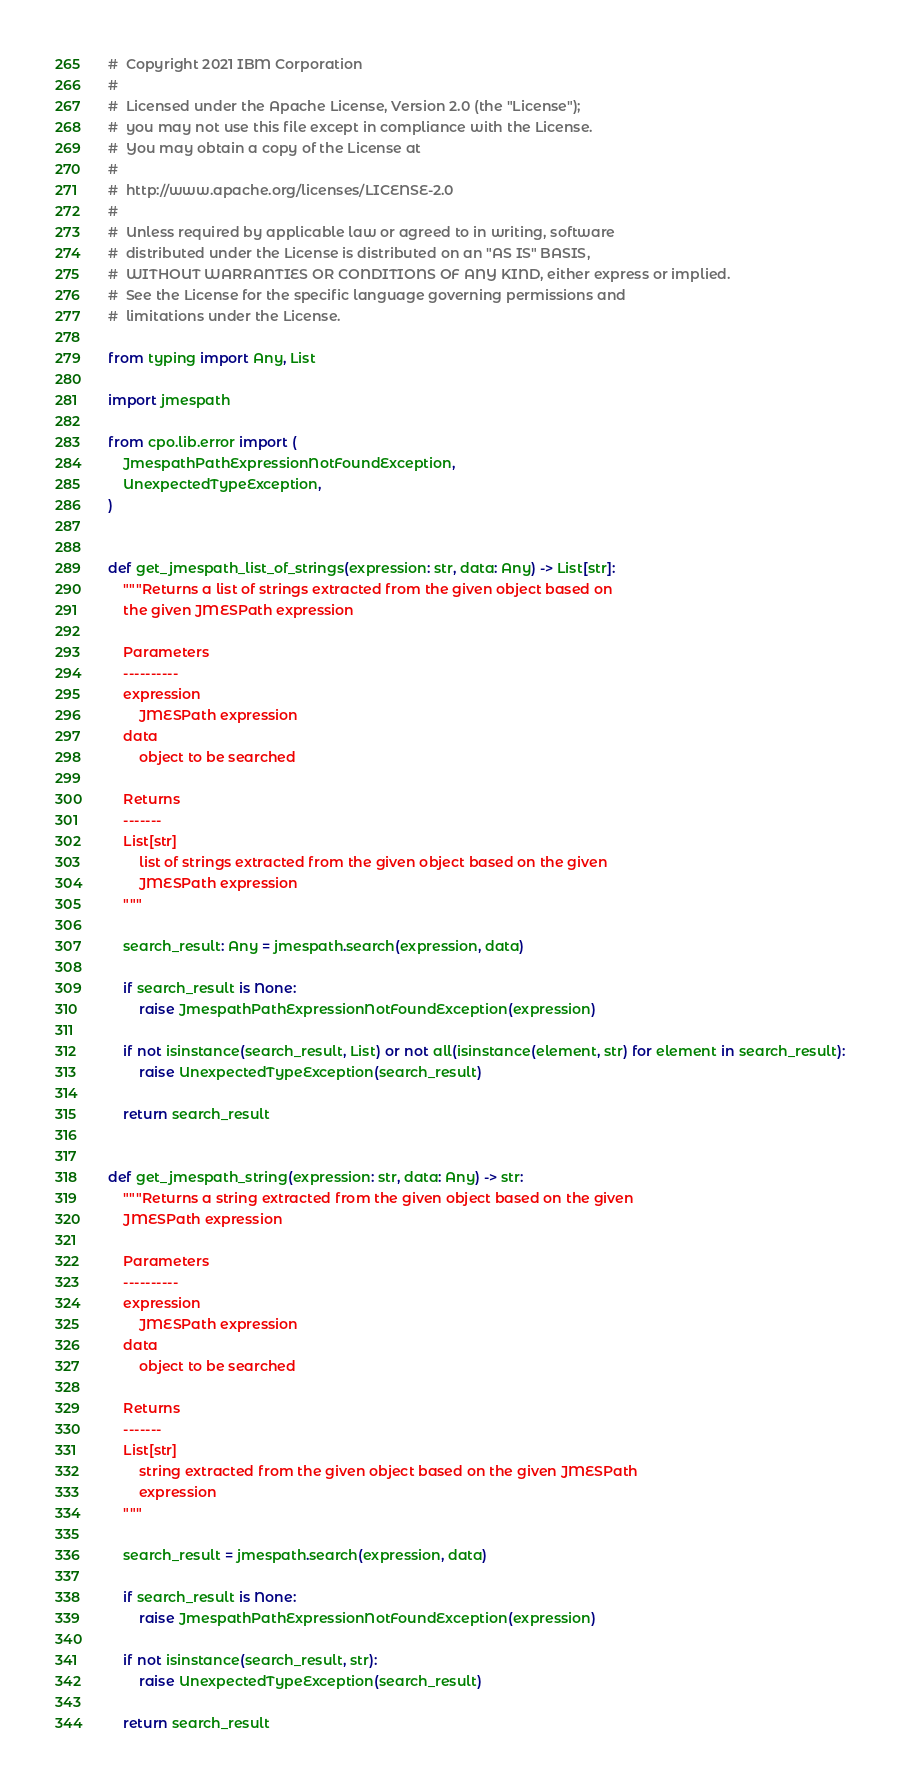<code> <loc_0><loc_0><loc_500><loc_500><_Python_>#  Copyright 2021 IBM Corporation
#
#  Licensed under the Apache License, Version 2.0 (the "License");
#  you may not use this file except in compliance with the License.
#  You may obtain a copy of the License at
#
#  http://www.apache.org/licenses/LICENSE-2.0
#
#  Unless required by applicable law or agreed to in writing, software
#  distributed under the License is distributed on an "AS IS" BASIS,
#  WITHOUT WARRANTIES OR CONDITIONS OF ANY KIND, either express or implied.
#  See the License for the specific language governing permissions and
#  limitations under the License.

from typing import Any, List

import jmespath

from cpo.lib.error import (
    JmespathPathExpressionNotFoundException,
    UnexpectedTypeException,
)


def get_jmespath_list_of_strings(expression: str, data: Any) -> List[str]:
    """Returns a list of strings extracted from the given object based on
    the given JMESPath expression

    Parameters
    ----------
    expression
        JMESPath expression
    data
        object to be searched

    Returns
    -------
    List[str]
        list of strings extracted from the given object based on the given
        JMESPath expression
    """

    search_result: Any = jmespath.search(expression, data)

    if search_result is None:
        raise JmespathPathExpressionNotFoundException(expression)

    if not isinstance(search_result, List) or not all(isinstance(element, str) for element in search_result):
        raise UnexpectedTypeException(search_result)

    return search_result


def get_jmespath_string(expression: str, data: Any) -> str:
    """Returns a string extracted from the given object based on the given
    JMESPath expression

    Parameters
    ----------
    expression
        JMESPath expression
    data
        object to be searched

    Returns
    -------
    List[str]
        string extracted from the given object based on the given JMESPath
        expression
    """

    search_result = jmespath.search(expression, data)

    if search_result is None:
        raise JmespathPathExpressionNotFoundException(expression)

    if not isinstance(search_result, str):
        raise UnexpectedTypeException(search_result)

    return search_result
</code> 